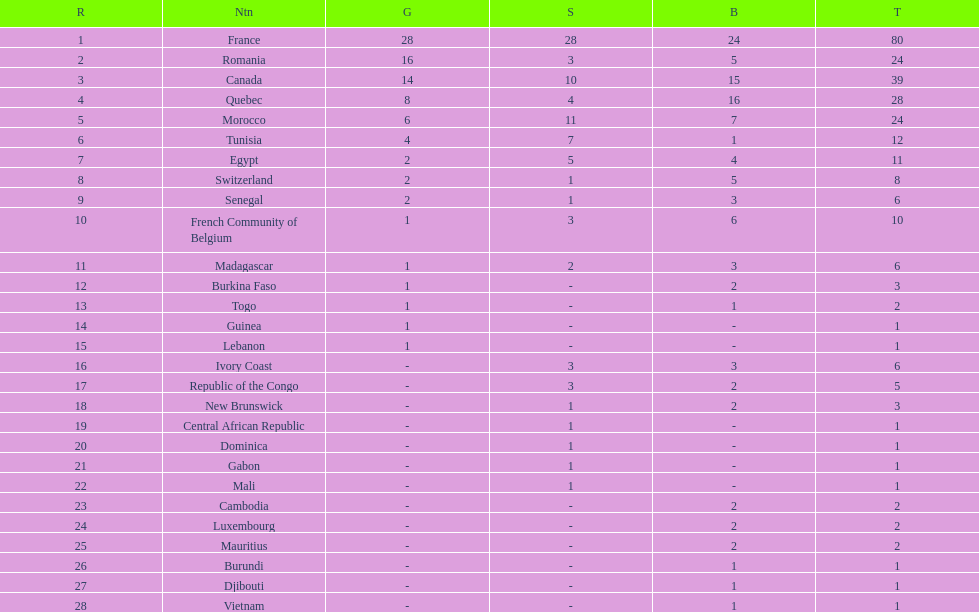What is the count of extra medals that egypt obtained in comparison to ivory coast? 5. 